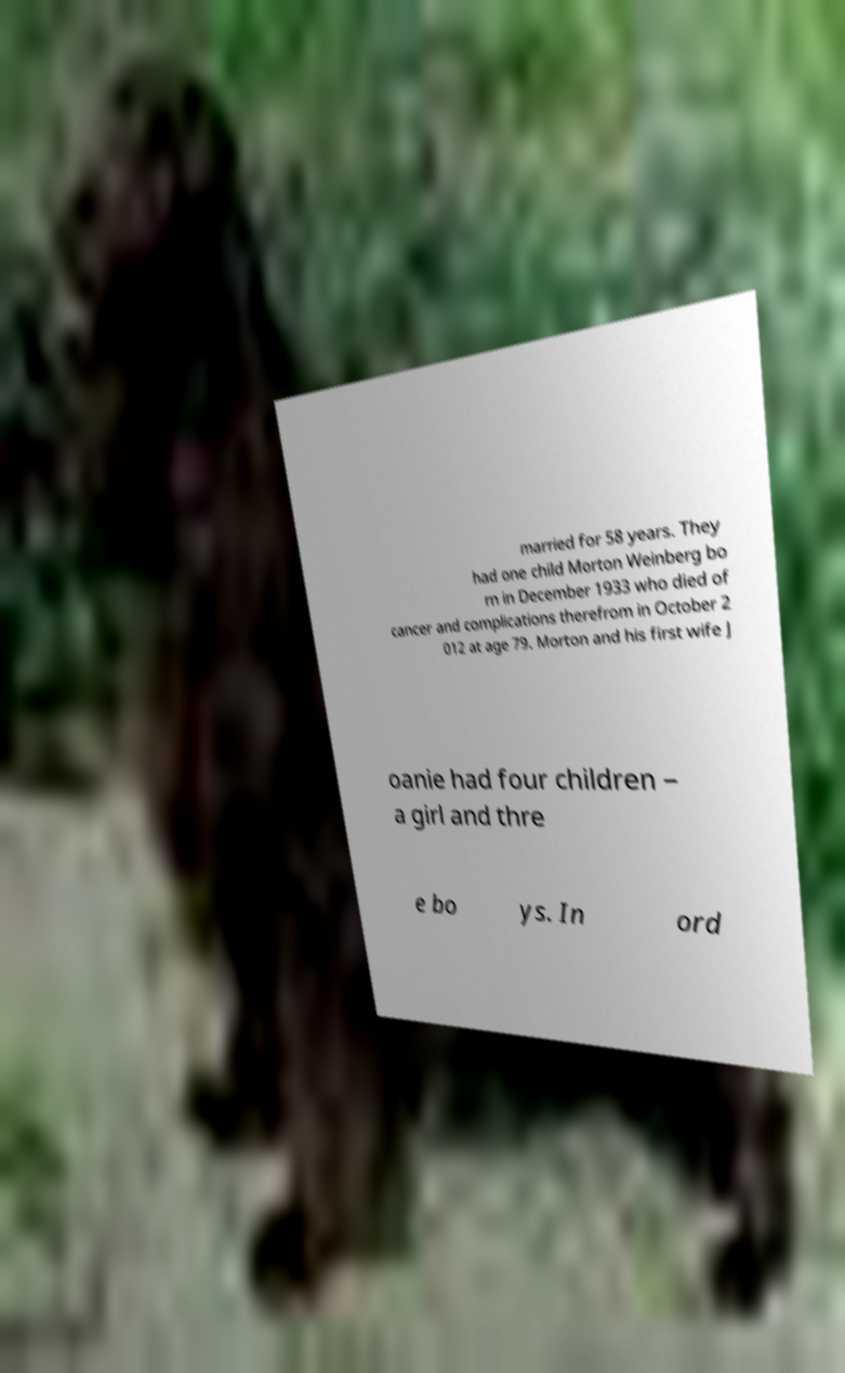There's text embedded in this image that I need extracted. Can you transcribe it verbatim? married for 58 years. They had one child Morton Weinberg bo rn in December 1933 who died of cancer and complications therefrom in October 2 012 at age 79. Morton and his first wife J oanie had four children – a girl and thre e bo ys. In ord 